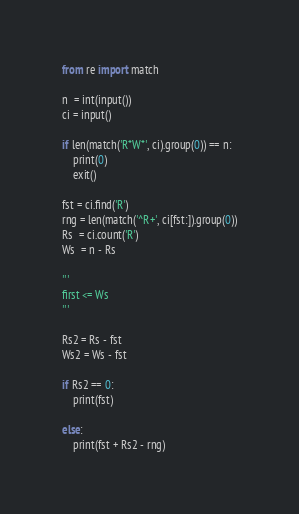<code> <loc_0><loc_0><loc_500><loc_500><_Python_>from re import match

n  = int(input())
ci = input()

if len(match('R*W*', ci).group(0)) == n:
    print(0)
    exit()

fst = ci.find('R')
rng = len(match('^R+', ci[fst:]).group(0))
Rs  = ci.count('R')
Ws  = n - Rs

'''
first <= Ws
'''

Rs2 = Rs - fst
Ws2 = Ws - fst

if Rs2 == 0:
    print(fst)

else:
    print(fst + Rs2 - rng)
</code> 